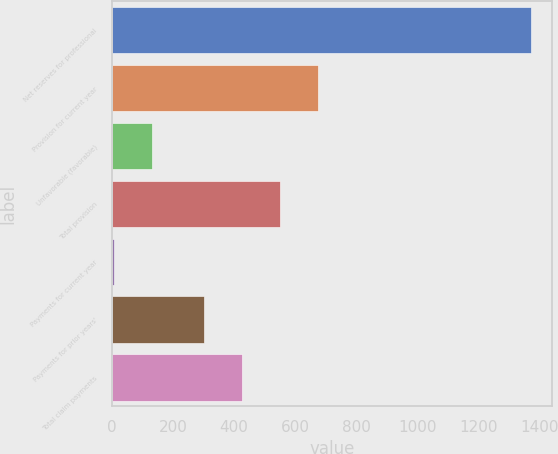Convert chart. <chart><loc_0><loc_0><loc_500><loc_500><bar_chart><fcel>Net reserves for professional<fcel>Provision for current year<fcel>Unfavorable (favorable)<fcel>Total provision<fcel>Payments for current year<fcel>Payments for prior years'<fcel>Total claim payments<nl><fcel>1372.8<fcel>674.4<fcel>131.8<fcel>549.6<fcel>7<fcel>300<fcel>424.8<nl></chart> 